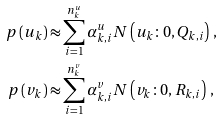<formula> <loc_0><loc_0><loc_500><loc_500>p \left ( u _ { k } \right ) \approx & \sum _ { i = 1 } ^ { n _ { k } ^ { u } } \alpha _ { k , i } ^ { u } N \left ( u _ { k } \colon 0 , Q _ { k , i } \right ) \, , \\ p \left ( v _ { k } \right ) \approx & \sum _ { i = 1 } ^ { n _ { k } ^ { v } } \alpha _ { k , i } ^ { v } N \left ( v _ { k } \colon 0 , R _ { k , i } \right ) \, ,</formula> 